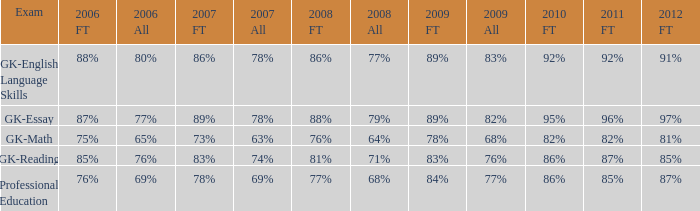What is the percentage for all in 2007 when all in 2006 was 65%? 63%. 